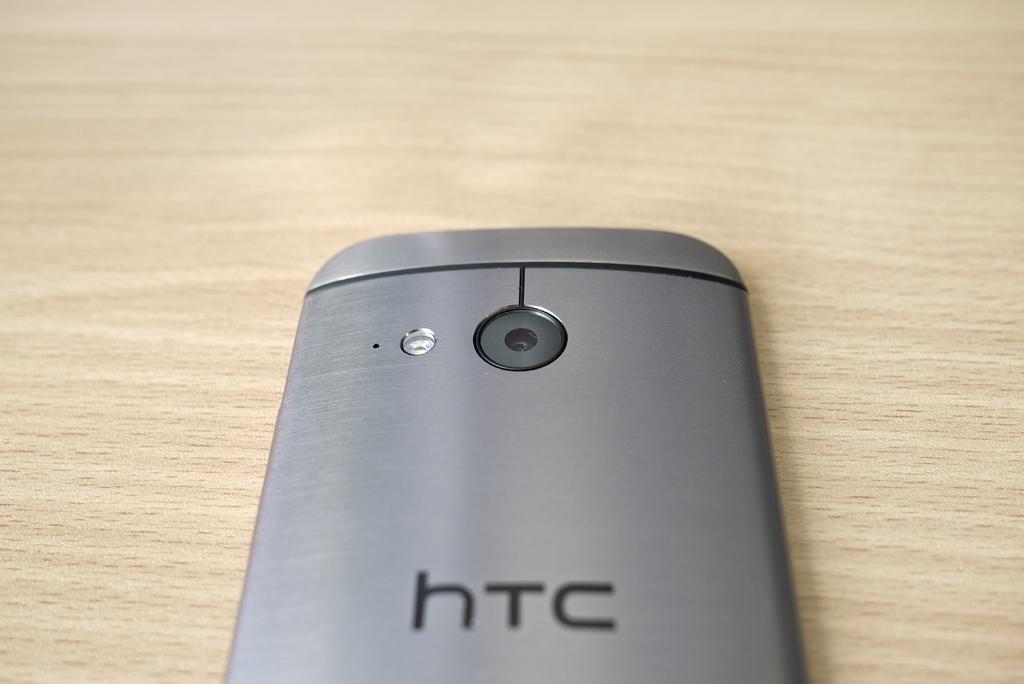Who manufactures this electronic?
Offer a very short reply. Htc. 